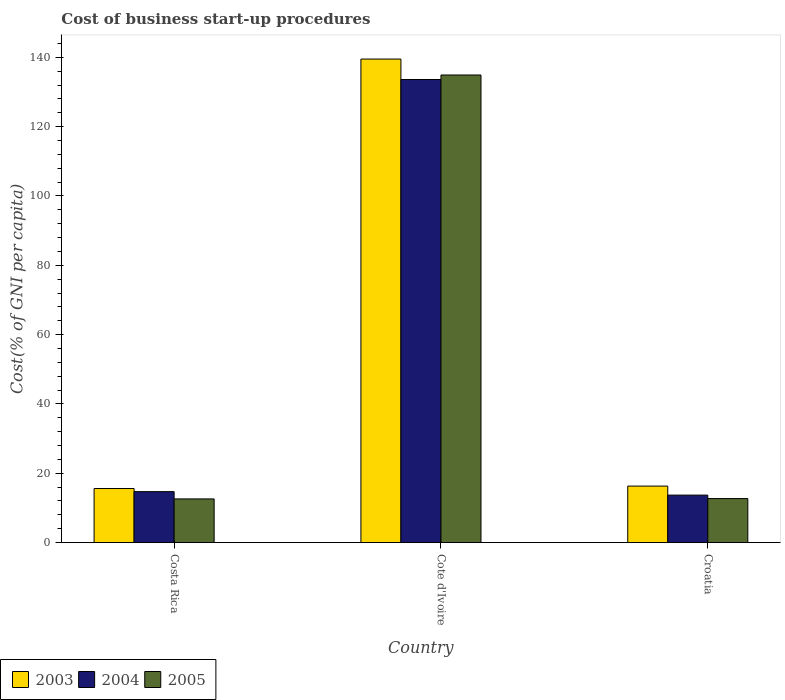How many different coloured bars are there?
Your answer should be compact. 3. How many groups of bars are there?
Ensure brevity in your answer.  3. How many bars are there on the 3rd tick from the left?
Offer a terse response. 3. How many bars are there on the 3rd tick from the right?
Provide a short and direct response. 3. What is the label of the 2nd group of bars from the left?
Your answer should be very brief. Cote d'Ivoire. In how many cases, is the number of bars for a given country not equal to the number of legend labels?
Your answer should be very brief. 0. What is the cost of business start-up procedures in 2005 in Croatia?
Provide a succinct answer. 12.7. Across all countries, what is the maximum cost of business start-up procedures in 2003?
Your answer should be very brief. 139.5. In which country was the cost of business start-up procedures in 2005 maximum?
Your response must be concise. Cote d'Ivoire. What is the total cost of business start-up procedures in 2004 in the graph?
Give a very brief answer. 162. What is the difference between the cost of business start-up procedures in 2004 in Costa Rica and that in Cote d'Ivoire?
Give a very brief answer. -118.9. What is the difference between the cost of business start-up procedures in 2003 in Croatia and the cost of business start-up procedures in 2005 in Cote d'Ivoire?
Your answer should be compact. -118.6. What is the average cost of business start-up procedures in 2005 per country?
Your answer should be very brief. 53.4. What is the difference between the cost of business start-up procedures of/in 2003 and cost of business start-up procedures of/in 2004 in Cote d'Ivoire?
Ensure brevity in your answer.  5.9. What is the ratio of the cost of business start-up procedures in 2003 in Cote d'Ivoire to that in Croatia?
Your answer should be very brief. 8.56. Is the cost of business start-up procedures in 2005 in Cote d'Ivoire less than that in Croatia?
Offer a very short reply. No. Is the difference between the cost of business start-up procedures in 2003 in Costa Rica and Cote d'Ivoire greater than the difference between the cost of business start-up procedures in 2004 in Costa Rica and Cote d'Ivoire?
Provide a succinct answer. No. What is the difference between the highest and the second highest cost of business start-up procedures in 2004?
Your response must be concise. -119.9. What is the difference between the highest and the lowest cost of business start-up procedures in 2005?
Make the answer very short. 122.3. Is the sum of the cost of business start-up procedures in 2004 in Cote d'Ivoire and Croatia greater than the maximum cost of business start-up procedures in 2003 across all countries?
Offer a very short reply. Yes. What does the 1st bar from the left in Cote d'Ivoire represents?
Offer a terse response. 2003. What does the 3rd bar from the right in Cote d'Ivoire represents?
Give a very brief answer. 2003. Is it the case that in every country, the sum of the cost of business start-up procedures in 2005 and cost of business start-up procedures in 2004 is greater than the cost of business start-up procedures in 2003?
Provide a succinct answer. Yes. How many bars are there?
Keep it short and to the point. 9. What is the difference between two consecutive major ticks on the Y-axis?
Your answer should be compact. 20. Are the values on the major ticks of Y-axis written in scientific E-notation?
Your answer should be very brief. No. What is the title of the graph?
Your answer should be very brief. Cost of business start-up procedures. What is the label or title of the X-axis?
Your answer should be compact. Country. What is the label or title of the Y-axis?
Offer a very short reply. Cost(% of GNI per capita). What is the Cost(% of GNI per capita) in 2003 in Costa Rica?
Offer a very short reply. 15.6. What is the Cost(% of GNI per capita) in 2004 in Costa Rica?
Your answer should be compact. 14.7. What is the Cost(% of GNI per capita) in 2003 in Cote d'Ivoire?
Offer a very short reply. 139.5. What is the Cost(% of GNI per capita) of 2004 in Cote d'Ivoire?
Ensure brevity in your answer.  133.6. What is the Cost(% of GNI per capita) in 2005 in Cote d'Ivoire?
Offer a very short reply. 134.9. What is the Cost(% of GNI per capita) in 2003 in Croatia?
Provide a short and direct response. 16.3. What is the Cost(% of GNI per capita) of 2005 in Croatia?
Offer a very short reply. 12.7. Across all countries, what is the maximum Cost(% of GNI per capita) in 2003?
Give a very brief answer. 139.5. Across all countries, what is the maximum Cost(% of GNI per capita) of 2004?
Make the answer very short. 133.6. Across all countries, what is the maximum Cost(% of GNI per capita) of 2005?
Ensure brevity in your answer.  134.9. Across all countries, what is the minimum Cost(% of GNI per capita) in 2003?
Keep it short and to the point. 15.6. What is the total Cost(% of GNI per capita) in 2003 in the graph?
Your answer should be very brief. 171.4. What is the total Cost(% of GNI per capita) in 2004 in the graph?
Your answer should be very brief. 162. What is the total Cost(% of GNI per capita) of 2005 in the graph?
Make the answer very short. 160.2. What is the difference between the Cost(% of GNI per capita) in 2003 in Costa Rica and that in Cote d'Ivoire?
Offer a terse response. -123.9. What is the difference between the Cost(% of GNI per capita) of 2004 in Costa Rica and that in Cote d'Ivoire?
Your response must be concise. -118.9. What is the difference between the Cost(% of GNI per capita) in 2005 in Costa Rica and that in Cote d'Ivoire?
Provide a short and direct response. -122.3. What is the difference between the Cost(% of GNI per capita) in 2003 in Costa Rica and that in Croatia?
Your response must be concise. -0.7. What is the difference between the Cost(% of GNI per capita) in 2004 in Costa Rica and that in Croatia?
Ensure brevity in your answer.  1. What is the difference between the Cost(% of GNI per capita) in 2003 in Cote d'Ivoire and that in Croatia?
Provide a succinct answer. 123.2. What is the difference between the Cost(% of GNI per capita) in 2004 in Cote d'Ivoire and that in Croatia?
Your answer should be compact. 119.9. What is the difference between the Cost(% of GNI per capita) of 2005 in Cote d'Ivoire and that in Croatia?
Provide a succinct answer. 122.2. What is the difference between the Cost(% of GNI per capita) in 2003 in Costa Rica and the Cost(% of GNI per capita) in 2004 in Cote d'Ivoire?
Ensure brevity in your answer.  -118. What is the difference between the Cost(% of GNI per capita) of 2003 in Costa Rica and the Cost(% of GNI per capita) of 2005 in Cote d'Ivoire?
Your answer should be compact. -119.3. What is the difference between the Cost(% of GNI per capita) in 2004 in Costa Rica and the Cost(% of GNI per capita) in 2005 in Cote d'Ivoire?
Provide a short and direct response. -120.2. What is the difference between the Cost(% of GNI per capita) of 2003 in Costa Rica and the Cost(% of GNI per capita) of 2004 in Croatia?
Make the answer very short. 1.9. What is the difference between the Cost(% of GNI per capita) of 2004 in Costa Rica and the Cost(% of GNI per capita) of 2005 in Croatia?
Keep it short and to the point. 2. What is the difference between the Cost(% of GNI per capita) of 2003 in Cote d'Ivoire and the Cost(% of GNI per capita) of 2004 in Croatia?
Your response must be concise. 125.8. What is the difference between the Cost(% of GNI per capita) in 2003 in Cote d'Ivoire and the Cost(% of GNI per capita) in 2005 in Croatia?
Ensure brevity in your answer.  126.8. What is the difference between the Cost(% of GNI per capita) of 2004 in Cote d'Ivoire and the Cost(% of GNI per capita) of 2005 in Croatia?
Give a very brief answer. 120.9. What is the average Cost(% of GNI per capita) of 2003 per country?
Make the answer very short. 57.13. What is the average Cost(% of GNI per capita) in 2004 per country?
Offer a terse response. 54. What is the average Cost(% of GNI per capita) of 2005 per country?
Keep it short and to the point. 53.4. What is the difference between the Cost(% of GNI per capita) in 2003 and Cost(% of GNI per capita) in 2004 in Costa Rica?
Make the answer very short. 0.9. What is the difference between the Cost(% of GNI per capita) in 2004 and Cost(% of GNI per capita) in 2005 in Costa Rica?
Your answer should be very brief. 2.1. What is the ratio of the Cost(% of GNI per capita) of 2003 in Costa Rica to that in Cote d'Ivoire?
Provide a succinct answer. 0.11. What is the ratio of the Cost(% of GNI per capita) in 2004 in Costa Rica to that in Cote d'Ivoire?
Provide a short and direct response. 0.11. What is the ratio of the Cost(% of GNI per capita) in 2005 in Costa Rica to that in Cote d'Ivoire?
Provide a succinct answer. 0.09. What is the ratio of the Cost(% of GNI per capita) in 2003 in Costa Rica to that in Croatia?
Give a very brief answer. 0.96. What is the ratio of the Cost(% of GNI per capita) of 2004 in Costa Rica to that in Croatia?
Give a very brief answer. 1.07. What is the ratio of the Cost(% of GNI per capita) in 2005 in Costa Rica to that in Croatia?
Ensure brevity in your answer.  0.99. What is the ratio of the Cost(% of GNI per capita) in 2003 in Cote d'Ivoire to that in Croatia?
Offer a terse response. 8.56. What is the ratio of the Cost(% of GNI per capita) of 2004 in Cote d'Ivoire to that in Croatia?
Make the answer very short. 9.75. What is the ratio of the Cost(% of GNI per capita) of 2005 in Cote d'Ivoire to that in Croatia?
Offer a very short reply. 10.62. What is the difference between the highest and the second highest Cost(% of GNI per capita) of 2003?
Your answer should be very brief. 123.2. What is the difference between the highest and the second highest Cost(% of GNI per capita) of 2004?
Ensure brevity in your answer.  118.9. What is the difference between the highest and the second highest Cost(% of GNI per capita) in 2005?
Make the answer very short. 122.2. What is the difference between the highest and the lowest Cost(% of GNI per capita) in 2003?
Ensure brevity in your answer.  123.9. What is the difference between the highest and the lowest Cost(% of GNI per capita) in 2004?
Your answer should be compact. 119.9. What is the difference between the highest and the lowest Cost(% of GNI per capita) in 2005?
Offer a very short reply. 122.3. 